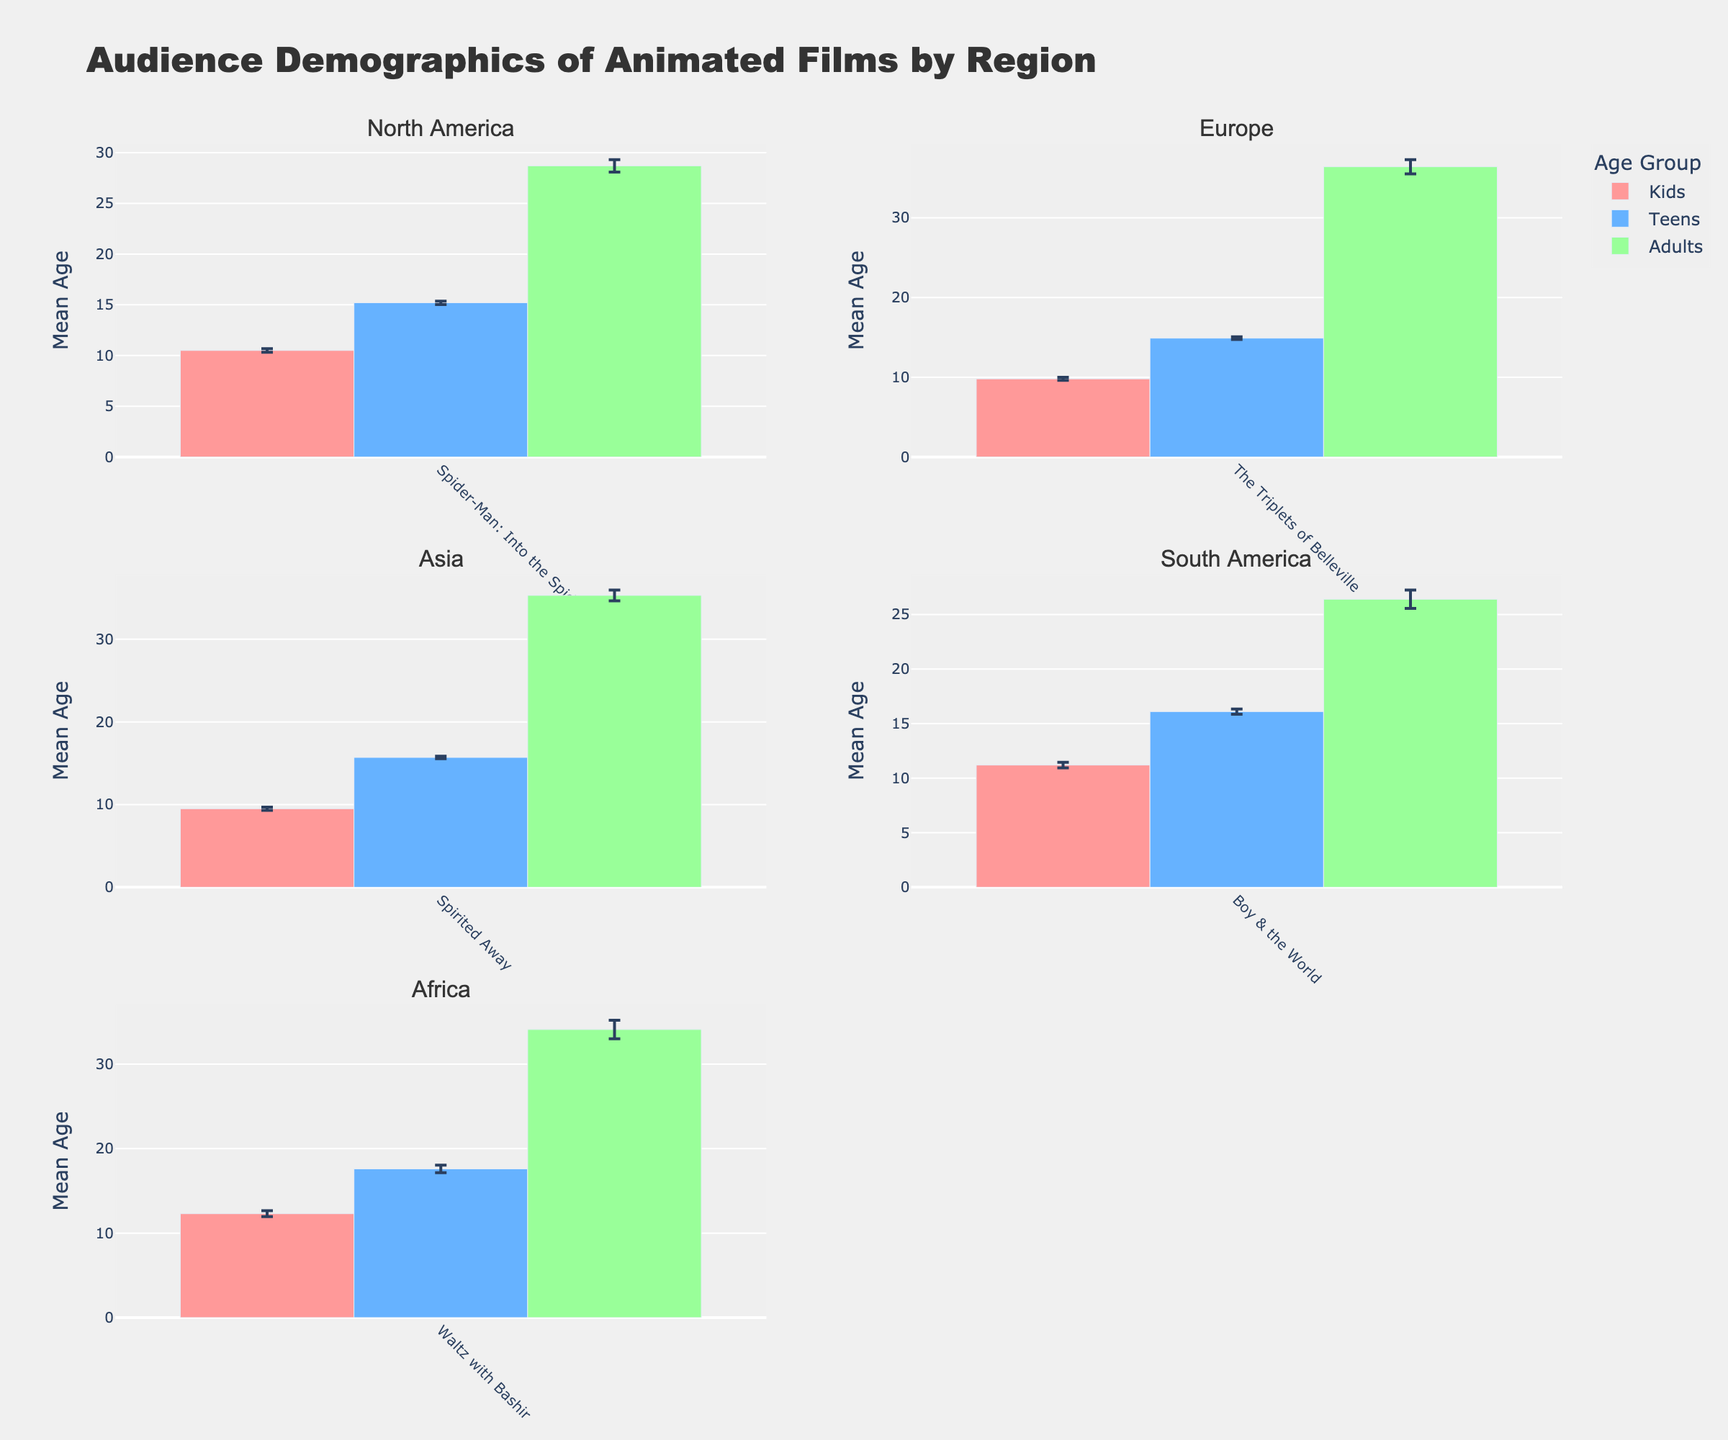What's the title of the figure? The title is usually displayed at the top of the figure. The provided code specifies the title as "Audience Demographics of Animated Films by Region."
Answer: Audience Demographics of Animated Films by Region What are the regions shown in the subplots? The subplot titles indicate the regions displayed. The regions shown are "North America," "Europe," "Asia," "South America," and "Africa."
Answer: North America, Europe, Asia, South America, Africa Which age group has the highest mean age in Europe? In the subplot titled "Europe," look at the bars representing each age group for the film "The Triplets of Belleville" and identify the one with the highest value on the y-axis. The "Adults" category has the highest mean age.
Answer: Adults Compare the mean age of Kids in North America and Kids in Asia. Which region has a higher mean age for Kids? Examine the bars representing the "Kids" category in the "North America" and "Asia" subplots. The heights of these bars will indicate the mean ages. North America's Kids have a mean age of 10.5, and Asia's Kids have a mean age of 9.5.
Answer: North America Which audience category in Africa has the smallest sample size? The subplot titled "Africa" illustrates the bars for each audience category. "Sample_Size" is not depicted in the figure, but knowing the data, the "Teens" category has the smallest sample size of 80. Use visual consistency for this response. Verify with the data provided.
Answer: Teens Calculate the margin of error for the mean age of Teens in South America. For South America Teens, the mean age is 16.1, the standard deviation is 1.7, and the sample size is 200. Margin of error = 1.96 * (Standard Deviation / sqrt(Sample Size)) = 1.96 * (1.7 / sqrt(200)) = 1.96 * 0.1204 = 0.235.
Answer: 0.235 Among all regions, which film has the highest mean age for Teens? Check the heights of the bars representing the "Teens" category across all subplot regions. "Waltz with Bashir" in Africa has the highest mean age for Teens at 17.6.
Answer: Waltz with Bashir What is the mean age range of Adults in all regions combined? Locate the bars for the "Adults" category in all subplots. The lowest value is from South America (26.4), and the highest value is from Europe (36.4). Hence, the range is 36.4 - 26.4 = 10.
Answer: 10 Which region has the largest variability in mean age for the Kids audience category? Variability can be inferred from the standard deviation, which is visually represented with error bars. Comparing the variability of the "Kids" category across all regions, Africa has a standard deviation of 1.8 with a considerably larger error bar relative to the other regions. Verify with the data provided.
Answer: Africa Is the mean age for Adults higher in Asia or in Europe? Look at the heights of the bars for the "Adults" category in the subplots for "Asia" and "Europe." Europe's bar for Adults is higher at 36.4 compared to Asia's 35.3.
Answer: Europe 